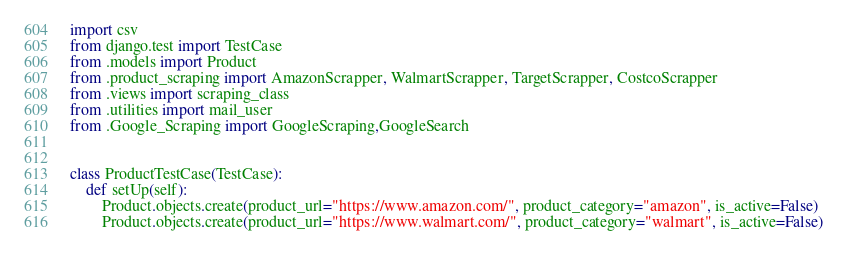<code> <loc_0><loc_0><loc_500><loc_500><_Python_>import csv
from django.test import TestCase
from .models import Product
from .product_scraping import AmazonScrapper, WalmartScrapper, TargetScrapper, CostcoScrapper
from .views import scraping_class
from .utilities import mail_user
from .Google_Scraping import GoogleScraping,GoogleSearch


class ProductTestCase(TestCase):
    def setUp(self):
        Product.objects.create(product_url="https://www.amazon.com/", product_category="amazon", is_active=False)
        Product.objects.create(product_url="https://www.walmart.com/", product_category="walmart", is_active=False)
</code> 